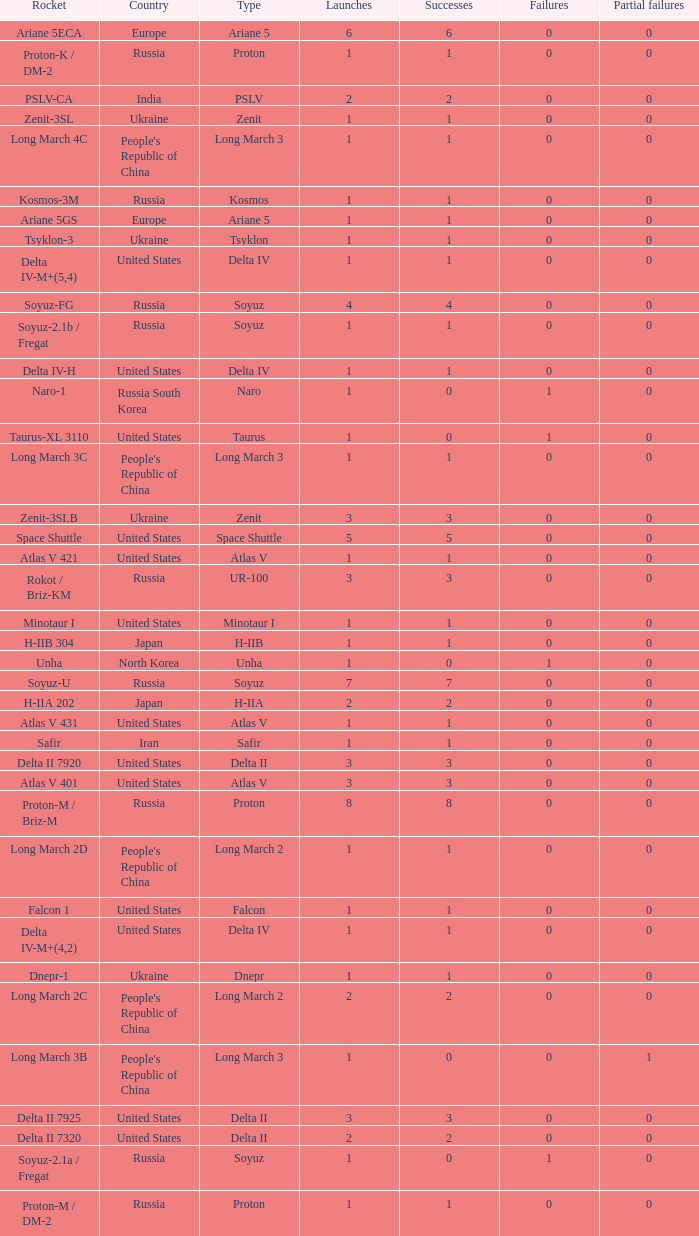What is the number of successes for rockets that have more than 3 launches, were based in Russia, are type soyuz and a rocket type of soyuz-u? 1.0. 